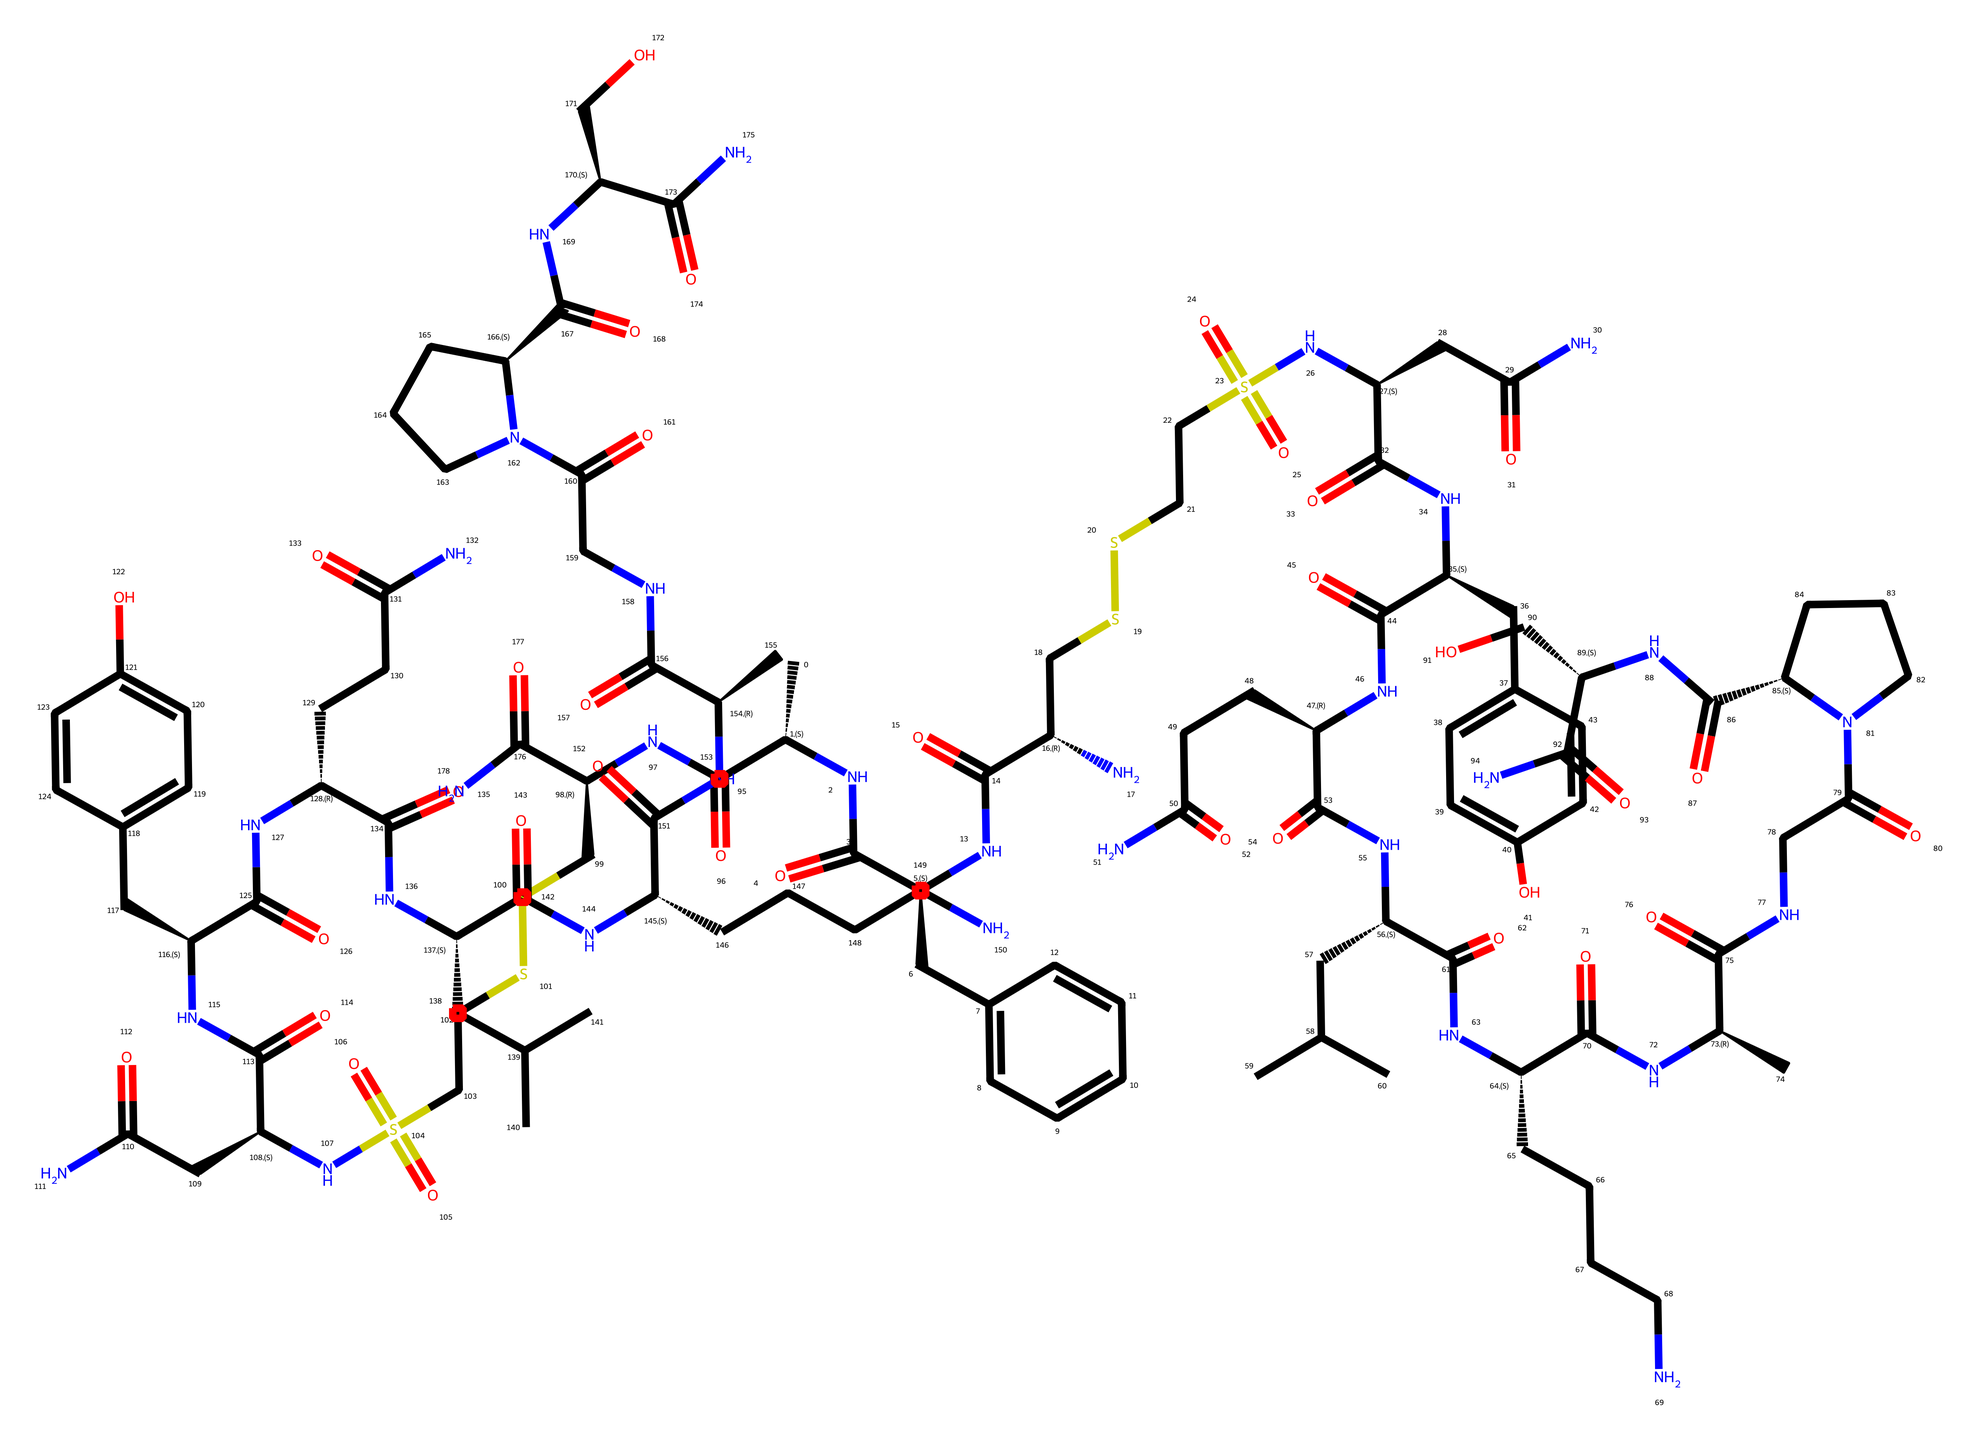What is the main function of oxytocin in the body? Oxytocin is often referred to as the "love hormone" because it plays a significant role in social bonding, sexual reproduction, and during and after childbirth.
Answer: love hormone How many carbon atoms are present in oxytocin? By analyzing the SMILES notation, we can count the number of carbon (C) symbols present, which indicates the number of carbon atoms. There are 39 carbon atoms.
Answer: 39 What type of molecule is oxytocin classified as? Oxytocin is a peptide hormone composed of amino acids. The structure contains a sequence of amino acids suggesting its classification.
Answer: peptide hormone What functional groups can be identified in oxytocin? Reviewing the chemical structure, we can identify functional groups such as amides (due to the presence of C=O and NH bonds), and thiols (due to the presence of -SH groups), indicating multiple functional groups.
Answer: amide, thiol Which part of the oxytocin molecule is crucial for its binding to receptors? The specific arrangement of amino acids in the peptide chain plays a critical role in its biological activity and receptor binding characteristics.
Answer: amino acid arrangement How many nitrogen atoms are in the oxytocin molecule? Counting the nitrogen (N) symbols in the SMILES representation allows us to determine the number of nitrogen atoms present. There are 8 nitrogen atoms.
Answer: 8 What amino acids are featured in oxytocin's structure? Analyzing the peptide sequence in the structure reveals the presence of specific amino acids, such as proline, leucine, and glycine, which are crucial for its biological function.
Answer: proline, leucine, glycine 